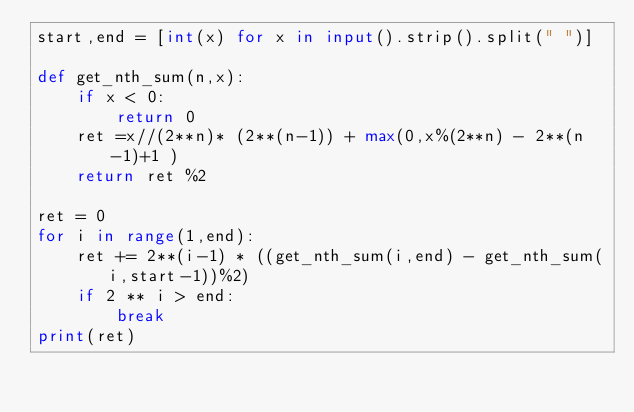Convert code to text. <code><loc_0><loc_0><loc_500><loc_500><_Python_>start,end = [int(x) for x in input().strip().split(" ")]

def get_nth_sum(n,x):
    if x < 0:
        return 0
    ret =x//(2**n)* (2**(n-1)) + max(0,x%(2**n) - 2**(n-1)+1 ) 
    return ret %2

ret = 0
for i in range(1,end):
    ret += 2**(i-1) * ((get_nth_sum(i,end) - get_nth_sum(i,start-1))%2)
    if 2 ** i > end:
        break
print(ret) </code> 